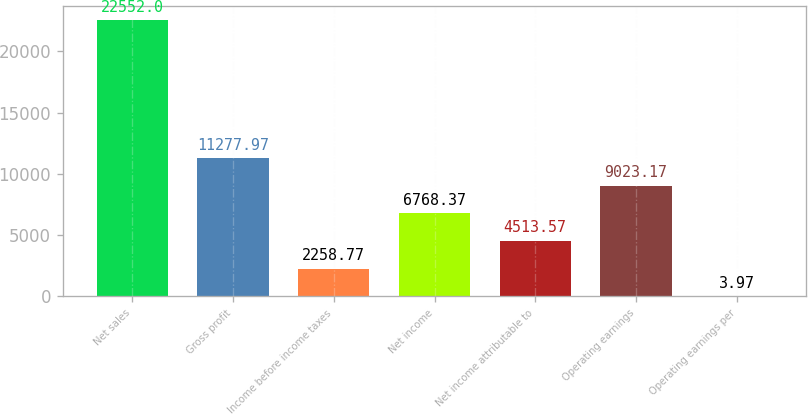Convert chart. <chart><loc_0><loc_0><loc_500><loc_500><bar_chart><fcel>Net sales<fcel>Gross profit<fcel>Income before income taxes<fcel>Net income<fcel>Net income attributable to<fcel>Operating earnings<fcel>Operating earnings per<nl><fcel>22552<fcel>11278<fcel>2258.77<fcel>6768.37<fcel>4513.57<fcel>9023.17<fcel>3.97<nl></chart> 